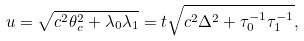<formula> <loc_0><loc_0><loc_500><loc_500>u = \sqrt { c ^ { 2 } \theta _ { c } ^ { 2 } + \lambda _ { 0 } \lambda _ { 1 } } = t \sqrt { c ^ { 2 } \Delta ^ { 2 } + \tau _ { 0 } ^ { - 1 } \tau _ { 1 } ^ { - 1 } } ,</formula> 